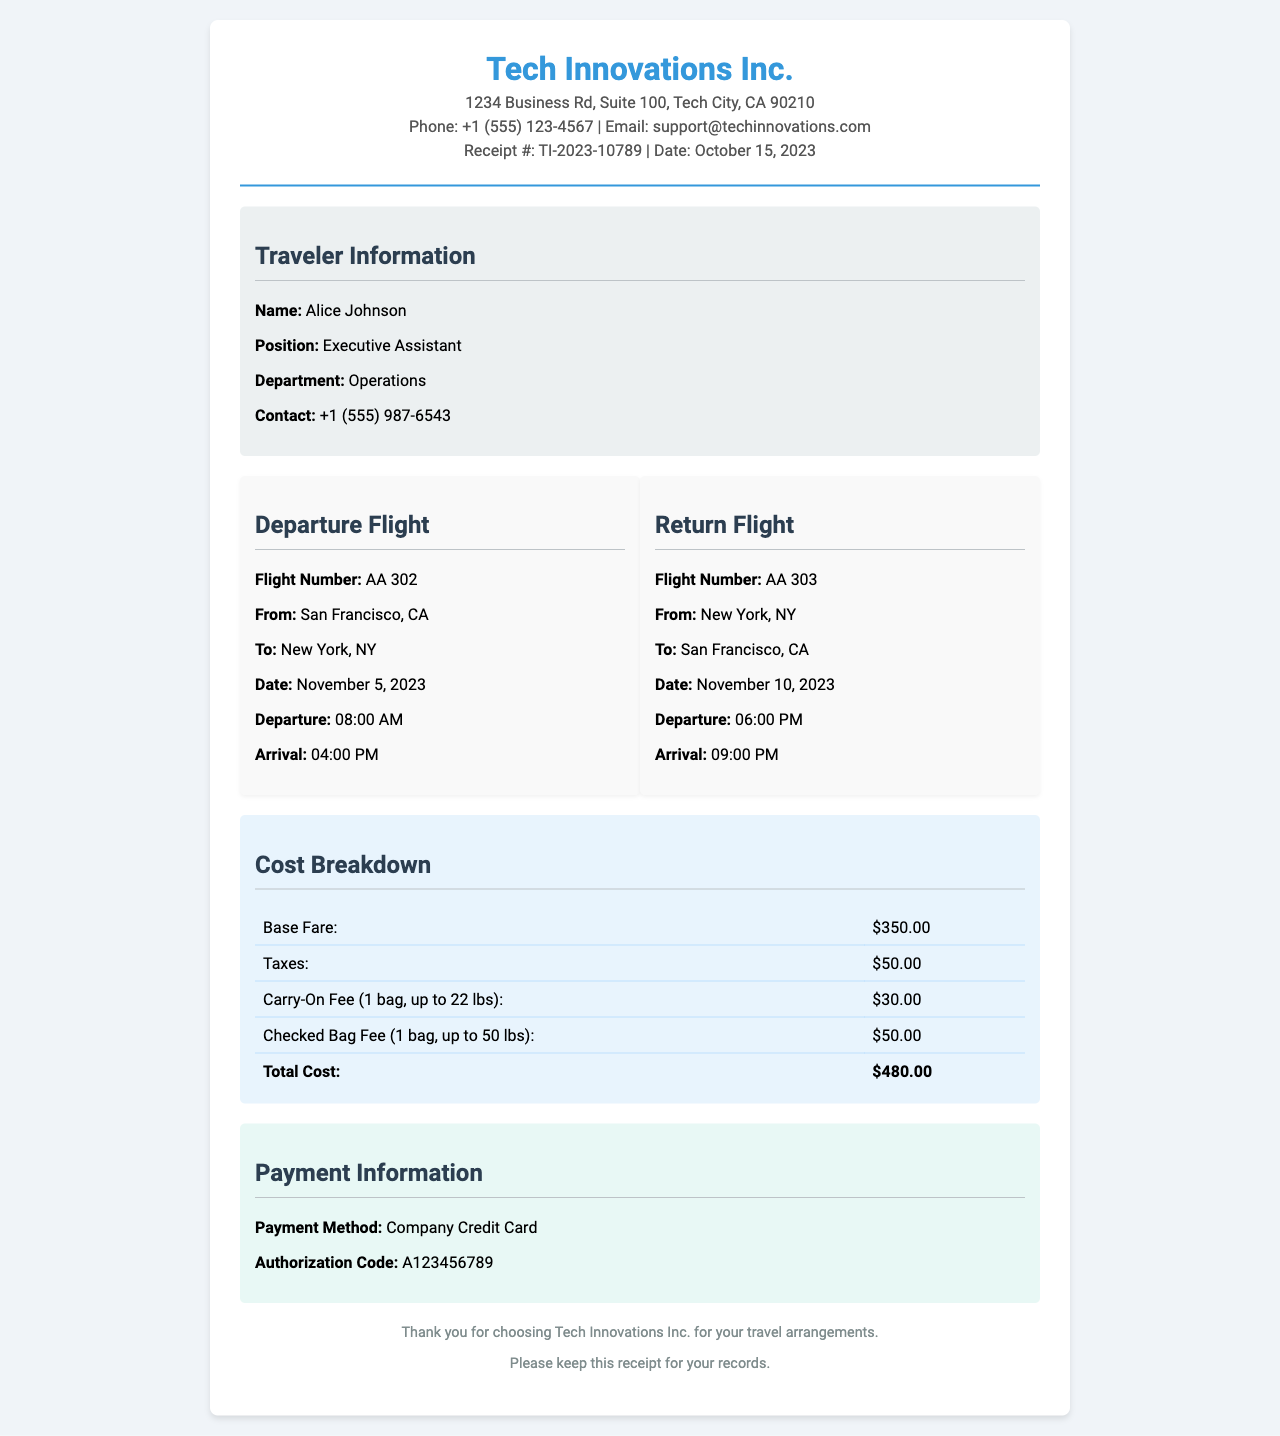What is the receipt number? The receipt number is located at the top of the document under receipt details, specifically stated as TI-2023-10789.
Answer: TI-2023-10789 What is the total airfare? The total airfare is mentioned in the costs section as the final total amount calculated, which adds up all costs.
Answer: $480.00 Who is the traveler? The traveler's name is found in the traveler information section, specifying who the receipt is for.
Answer: Alice Johnson What is the departure flight number? The departure flight number is detailed in the flight details section specific to the outbound flight.
Answer: AA 302 What is the checked bag fee? The checked bag fee is listed in the cost breakdown, specifying the additional charge for the checked luggage.
Answer: $50.00 How many bags are allowed for the carry-on fee? The carry-on fee specifies the allowed amount and weight for the additional charge.
Answer: 1 bag, up to 22 lbs What is the departure date for the return flight? The return flight's departure date is noted in the flight details section under the return flight specifics.
Answer: November 10, 2023 What payment method was used? The payment method is stated in the payment information section, showing how the purchase was processed.
Answer: Company Credit Card What is the arrival time for the departure flight? The arrival time for the departure flight is clearly mentioned in the flight details.
Answer: 04:00 PM 